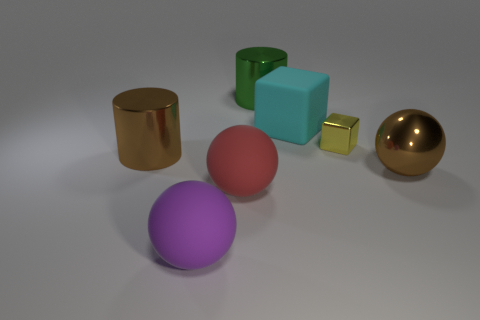Is there anything else that has the same size as the yellow thing?
Your response must be concise. No. There is a large thing that is both in front of the metal sphere and left of the red rubber ball; what is its shape?
Give a very brief answer. Sphere. There is a big brown object on the right side of the large ball that is in front of the big red object left of the brown sphere; what is its material?
Your answer should be compact. Metal. Is the number of big cyan blocks that are left of the purple matte sphere greater than the number of large green metal cylinders right of the brown metal sphere?
Your answer should be compact. No. How many brown cylinders are made of the same material as the big green cylinder?
Provide a succinct answer. 1. Does the brown metallic thing on the left side of the brown ball have the same shape as the brown object that is on the right side of the yellow thing?
Your answer should be very brief. No. There is a cylinder that is left of the big purple ball; what is its color?
Keep it short and to the point. Brown. Are there any matte objects that have the same shape as the yellow metallic thing?
Give a very brief answer. Yes. What is the material of the large cube?
Your answer should be compact. Rubber. What size is the sphere that is on the right side of the big purple sphere and left of the green cylinder?
Your answer should be very brief. Large. 